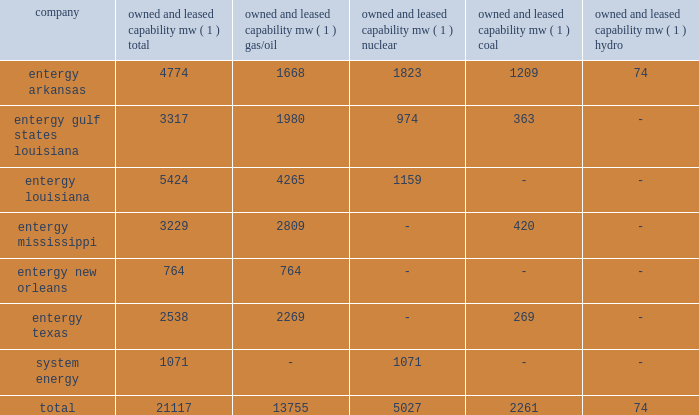Part i item 1 entergy corporation , utility operating companies , and system energy entergy new orleans provides electric and gas service in the city of new orleans pursuant to indeterminate permits set forth in city ordinances ( except electric service in algiers , which is provided by entergy louisiana ) .
These ordinances contain a continuing option for the city of new orleans to purchase entergy new orleans 2019s electric and gas utility properties .
Entergy texas holds a certificate of convenience and necessity from the puct to provide electric service to areas within approximately 27 counties in eastern texas , and holds non-exclusive franchises to provide electric service in approximately 68 incorporated municipalities .
Entergy texas was typically granted 50-year franchises , but recently has been receiving 25-year franchises .
Entergy texas 2019s electric franchises expire during 2013-2058 .
The business of system energy is limited to wholesale power sales .
It has no distribution franchises .
Property and other generation resources generating stations the total capability of the generating stations owned and leased by the utility operating companies and system energy as of december 31 , 2011 , is indicated below: .
( 1 ) 201cowned and leased capability 201d is the dependable load carrying capability as demonstrated under actual operating conditions based on the primary fuel ( assuming no curtailments ) that each station was designed to utilize .
The entergy system's load and capacity projections are reviewed periodically to assess the need and timing for additional generating capacity and interconnections .
These reviews consider existing and projected demand , the availability and price of power , the location of new load , and the economy .
Summer peak load in the entergy system service territory has averaged 21246 mw from 2002-2011 .
In the 2002 time period , the entergy system's long-term capacity resources , allowing for an adequate reserve margin , were approximately 3000 mw less than the total capacity required for peak period demands .
In this time period the entergy system met its capacity shortages almost entirely through short-term power purchases in the wholesale spot market .
In the fall of 2002 , the entergy system began a program to add new resources to its existing generation portfolio and began a process of issuing requests for proposals ( rfp ) to procure supply-side resources from sources other than the spot market to meet the unique regional needs of the utility operating companies .
The entergy system has adopted a long-term resource strategy that calls for the bulk of capacity needs to be met through long-term resources , whether owned or contracted .
Entergy refers to this strategy as the "portfolio transformation strategy" .
Over the past nine years , portfolio transformation has resulted in the addition of about 4500 mw of new long-term resources .
These figures do not include transactions currently pending as a result of the summer 2009 rfp .
When the summer 2009 rfp transactions are included in the entergy system portfolio of long-term resources and adjusting for unit deactivations of older generation , the entergy system is approximately 500 mw short of its projected 2012 peak load plus reserve margin .
This remaining need is expected to be met through a nuclear uprate at grand gulf and limited-term resources .
The entergy system will continue to access the spot power market to economically .
What portion of the total capabilities is generated from coal stations for entergy arkansas? 
Computations: (1209 / 4774)
Answer: 0.25325. 